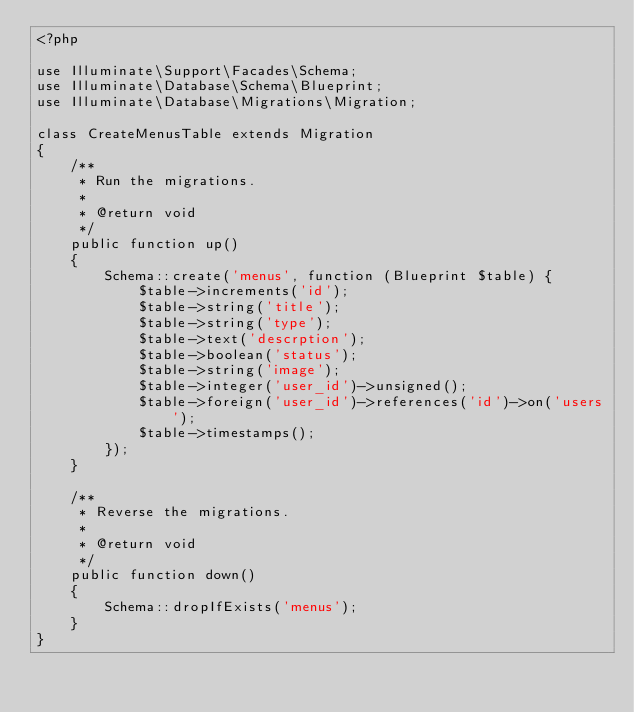Convert code to text. <code><loc_0><loc_0><loc_500><loc_500><_PHP_><?php

use Illuminate\Support\Facades\Schema;
use Illuminate\Database\Schema\Blueprint;
use Illuminate\Database\Migrations\Migration;

class CreateMenusTable extends Migration
{
    /**
     * Run the migrations.
     *
     * @return void
     */
    public function up()
    {
        Schema::create('menus', function (Blueprint $table) {
            $table->increments('id');
            $table->string('title');
            $table->string('type');
            $table->text('descrption');
            $table->boolean('status');
            $table->string('image');
            $table->integer('user_id')->unsigned();
            $table->foreign('user_id')->references('id')->on('users');
            $table->timestamps();
        });
    }

    /**
     * Reverse the migrations.
     *
     * @return void
     */
    public function down()
    {
        Schema::dropIfExists('menus');
    }
}
</code> 